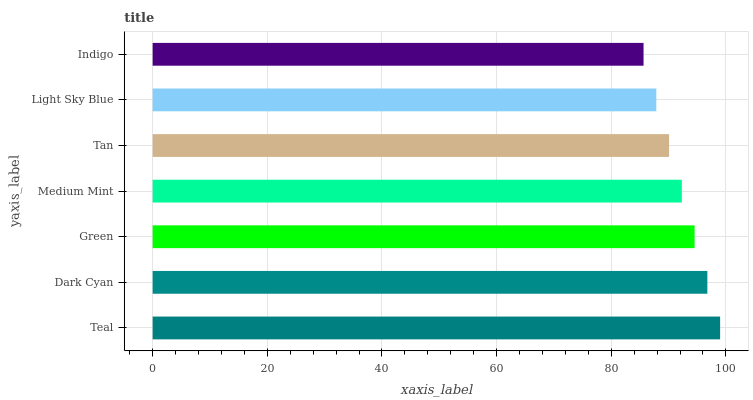Is Indigo the minimum?
Answer yes or no. Yes. Is Teal the maximum?
Answer yes or no. Yes. Is Dark Cyan the minimum?
Answer yes or no. No. Is Dark Cyan the maximum?
Answer yes or no. No. Is Teal greater than Dark Cyan?
Answer yes or no. Yes. Is Dark Cyan less than Teal?
Answer yes or no. Yes. Is Dark Cyan greater than Teal?
Answer yes or no. No. Is Teal less than Dark Cyan?
Answer yes or no. No. Is Medium Mint the high median?
Answer yes or no. Yes. Is Medium Mint the low median?
Answer yes or no. Yes. Is Light Sky Blue the high median?
Answer yes or no. No. Is Indigo the low median?
Answer yes or no. No. 